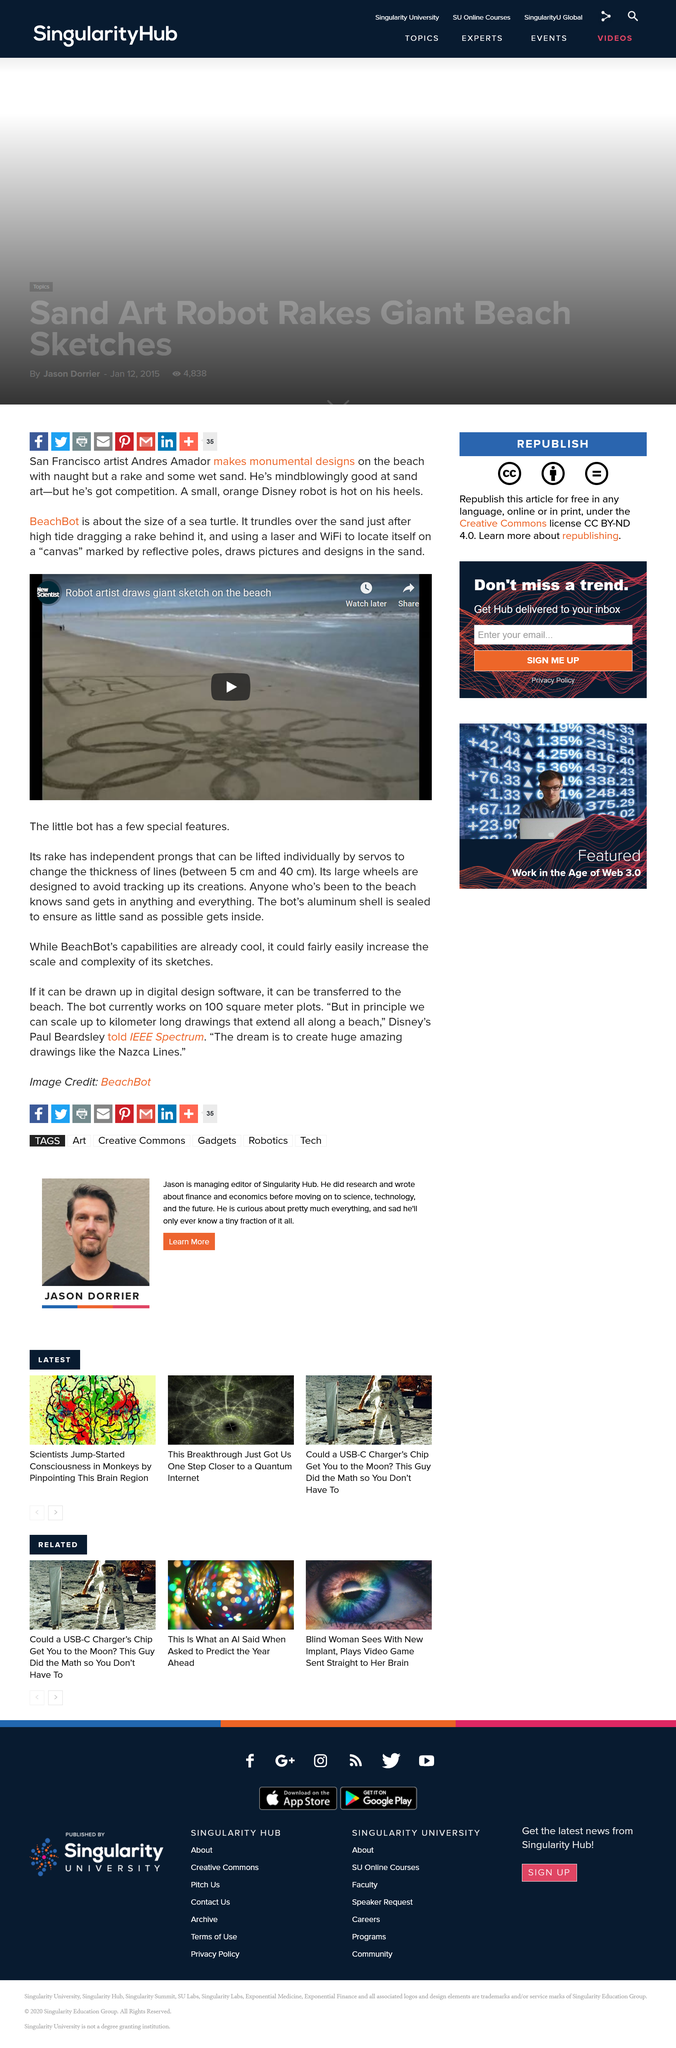Give some essential details in this illustration. BeachBot is approximately the size of a sea turtle, making it a compact and portable solution for monitoring beaches. WiFi and lasers are utilized by the device to determine its location. The use of a sealed aluminum shell on the bot ensures that minimal sand enters its interior. 